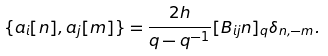<formula> <loc_0><loc_0><loc_500><loc_500>\{ a _ { i } [ n ] , a _ { j } [ m ] \} = \frac { 2 h } { q - q ^ { - 1 } } [ B _ { i j } n ] _ { q } \delta _ { n , - m } .</formula> 